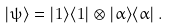Convert formula to latex. <formula><loc_0><loc_0><loc_500><loc_500>| \psi \rangle = | 1 \rangle \langle 1 | \otimes | \alpha \rangle \langle \alpha | \, .</formula> 